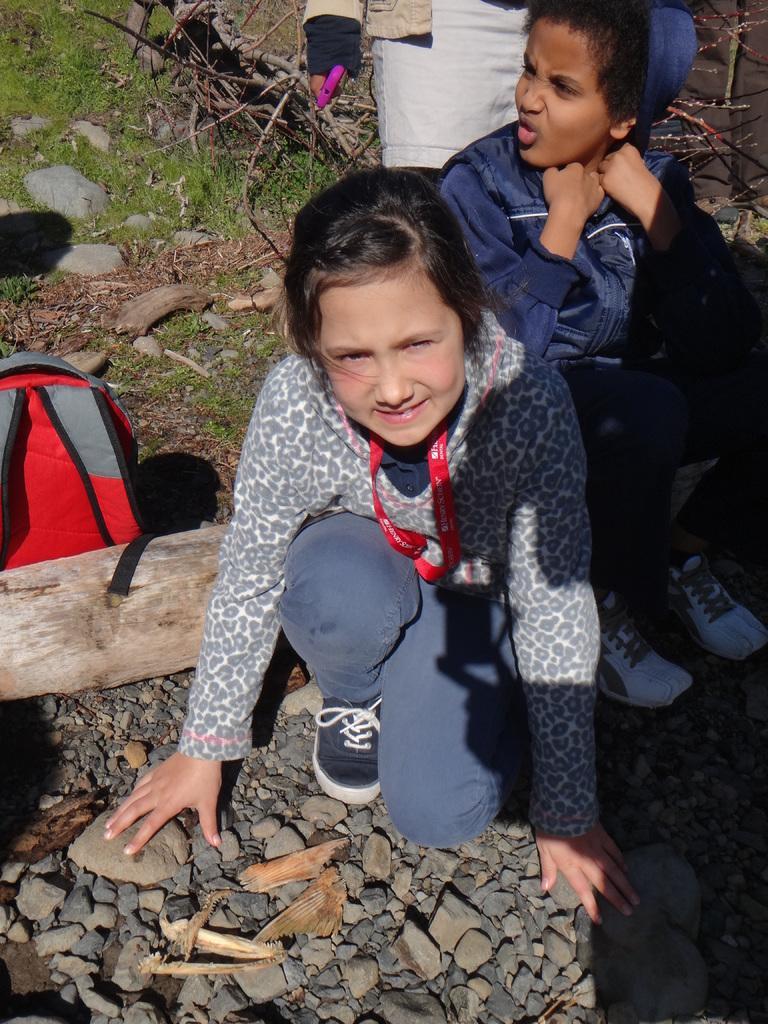How would you summarize this image in a sentence or two? In the center of the image there is a kid sitting on the ground. In the left side of the image there is a bag. On the right side of the image we can see kids. In the background there are stones, grass and plants. 